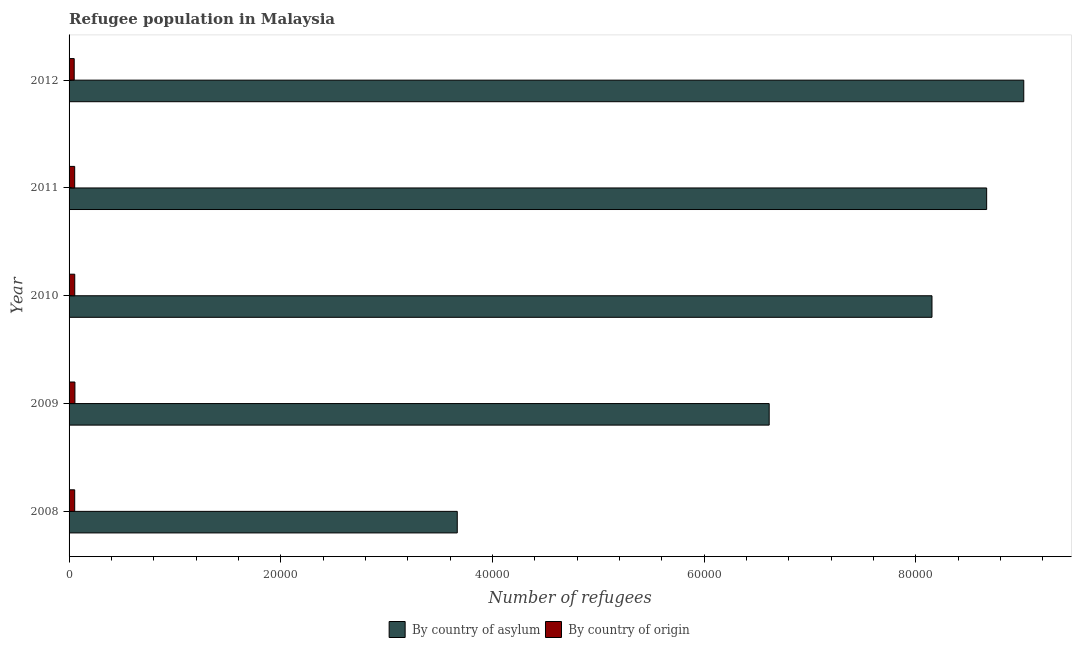How many groups of bars are there?
Keep it short and to the point. 5. How many bars are there on the 1st tick from the top?
Provide a short and direct response. 2. What is the number of refugees by country of origin in 2011?
Your answer should be very brief. 531. Across all years, what is the maximum number of refugees by country of origin?
Your answer should be very brief. 552. Across all years, what is the minimum number of refugees by country of origin?
Your response must be concise. 485. In which year was the number of refugees by country of origin maximum?
Your answer should be compact. 2009. In which year was the number of refugees by country of asylum minimum?
Ensure brevity in your answer.  2008. What is the total number of refugees by country of origin in the graph?
Provide a short and direct response. 2637. What is the difference between the number of refugees by country of origin in 2009 and that in 2012?
Make the answer very short. 67. What is the difference between the number of refugees by country of asylum in 2008 and the number of refugees by country of origin in 2012?
Your answer should be compact. 3.62e+04. What is the average number of refugees by country of origin per year?
Ensure brevity in your answer.  527.4. In the year 2011, what is the difference between the number of refugees by country of asylum and number of refugees by country of origin?
Provide a succinct answer. 8.61e+04. In how many years, is the number of refugees by country of origin greater than 12000 ?
Your answer should be very brief. 0. What is the ratio of the number of refugees by country of asylum in 2008 to that in 2011?
Ensure brevity in your answer.  0.42. What is the difference between the highest and the second highest number of refugees by country of origin?
Keep it short and to the point. 15. What is the difference between the highest and the lowest number of refugees by country of origin?
Provide a succinct answer. 67. Is the sum of the number of refugees by country of asylum in 2011 and 2012 greater than the maximum number of refugees by country of origin across all years?
Ensure brevity in your answer.  Yes. What does the 2nd bar from the top in 2010 represents?
Make the answer very short. By country of asylum. What does the 2nd bar from the bottom in 2009 represents?
Provide a succinct answer. By country of origin. How many bars are there?
Make the answer very short. 10. How many years are there in the graph?
Give a very brief answer. 5. Does the graph contain grids?
Provide a succinct answer. No. Where does the legend appear in the graph?
Your answer should be compact. Bottom center. What is the title of the graph?
Provide a short and direct response. Refugee population in Malaysia. Does "Female labourers" appear as one of the legend labels in the graph?
Your answer should be very brief. No. What is the label or title of the X-axis?
Provide a succinct answer. Number of refugees. What is the Number of refugees of By country of asylum in 2008?
Give a very brief answer. 3.67e+04. What is the Number of refugees of By country of origin in 2008?
Provide a short and direct response. 532. What is the Number of refugees of By country of asylum in 2009?
Your answer should be very brief. 6.61e+04. What is the Number of refugees of By country of origin in 2009?
Ensure brevity in your answer.  552. What is the Number of refugees of By country of asylum in 2010?
Provide a succinct answer. 8.15e+04. What is the Number of refugees of By country of origin in 2010?
Ensure brevity in your answer.  537. What is the Number of refugees of By country of asylum in 2011?
Provide a succinct answer. 8.67e+04. What is the Number of refugees in By country of origin in 2011?
Offer a terse response. 531. What is the Number of refugees in By country of asylum in 2012?
Ensure brevity in your answer.  9.02e+04. What is the Number of refugees in By country of origin in 2012?
Make the answer very short. 485. Across all years, what is the maximum Number of refugees of By country of asylum?
Give a very brief answer. 9.02e+04. Across all years, what is the maximum Number of refugees of By country of origin?
Your answer should be very brief. 552. Across all years, what is the minimum Number of refugees of By country of asylum?
Offer a terse response. 3.67e+04. Across all years, what is the minimum Number of refugees in By country of origin?
Your answer should be compact. 485. What is the total Number of refugees of By country of asylum in the graph?
Ensure brevity in your answer.  3.61e+05. What is the total Number of refugees in By country of origin in the graph?
Your response must be concise. 2637. What is the difference between the Number of refugees of By country of asylum in 2008 and that in 2009?
Offer a very short reply. -2.95e+04. What is the difference between the Number of refugees in By country of asylum in 2008 and that in 2010?
Provide a short and direct response. -4.48e+04. What is the difference between the Number of refugees in By country of origin in 2008 and that in 2010?
Offer a terse response. -5. What is the difference between the Number of refugees in By country of asylum in 2008 and that in 2011?
Give a very brief answer. -5.00e+04. What is the difference between the Number of refugees of By country of asylum in 2008 and that in 2012?
Your answer should be compact. -5.35e+04. What is the difference between the Number of refugees in By country of origin in 2008 and that in 2012?
Make the answer very short. 47. What is the difference between the Number of refugees of By country of asylum in 2009 and that in 2010?
Offer a very short reply. -1.54e+04. What is the difference between the Number of refugees of By country of asylum in 2009 and that in 2011?
Offer a terse response. -2.05e+04. What is the difference between the Number of refugees in By country of origin in 2009 and that in 2011?
Keep it short and to the point. 21. What is the difference between the Number of refugees of By country of asylum in 2009 and that in 2012?
Your answer should be compact. -2.40e+04. What is the difference between the Number of refugees in By country of asylum in 2010 and that in 2011?
Your answer should be compact. -5164. What is the difference between the Number of refugees in By country of origin in 2010 and that in 2011?
Offer a terse response. 6. What is the difference between the Number of refugees in By country of asylum in 2010 and that in 2012?
Ensure brevity in your answer.  -8669. What is the difference between the Number of refugees of By country of asylum in 2011 and that in 2012?
Offer a terse response. -3505. What is the difference between the Number of refugees of By country of origin in 2011 and that in 2012?
Offer a very short reply. 46. What is the difference between the Number of refugees of By country of asylum in 2008 and the Number of refugees of By country of origin in 2009?
Make the answer very short. 3.61e+04. What is the difference between the Number of refugees in By country of asylum in 2008 and the Number of refugees in By country of origin in 2010?
Offer a terse response. 3.61e+04. What is the difference between the Number of refugees in By country of asylum in 2008 and the Number of refugees in By country of origin in 2011?
Your answer should be compact. 3.61e+04. What is the difference between the Number of refugees in By country of asylum in 2008 and the Number of refugees in By country of origin in 2012?
Provide a succinct answer. 3.62e+04. What is the difference between the Number of refugees in By country of asylum in 2009 and the Number of refugees in By country of origin in 2010?
Offer a terse response. 6.56e+04. What is the difference between the Number of refugees in By country of asylum in 2009 and the Number of refugees in By country of origin in 2011?
Give a very brief answer. 6.56e+04. What is the difference between the Number of refugees in By country of asylum in 2009 and the Number of refugees in By country of origin in 2012?
Your answer should be very brief. 6.57e+04. What is the difference between the Number of refugees of By country of asylum in 2010 and the Number of refugees of By country of origin in 2011?
Make the answer very short. 8.10e+04. What is the difference between the Number of refugees of By country of asylum in 2010 and the Number of refugees of By country of origin in 2012?
Give a very brief answer. 8.10e+04. What is the difference between the Number of refugees of By country of asylum in 2011 and the Number of refugees of By country of origin in 2012?
Offer a very short reply. 8.62e+04. What is the average Number of refugees in By country of asylum per year?
Your answer should be very brief. 7.22e+04. What is the average Number of refugees in By country of origin per year?
Your answer should be compact. 527.4. In the year 2008, what is the difference between the Number of refugees in By country of asylum and Number of refugees in By country of origin?
Your answer should be compact. 3.61e+04. In the year 2009, what is the difference between the Number of refugees of By country of asylum and Number of refugees of By country of origin?
Ensure brevity in your answer.  6.56e+04. In the year 2010, what is the difference between the Number of refugees in By country of asylum and Number of refugees in By country of origin?
Offer a terse response. 8.10e+04. In the year 2011, what is the difference between the Number of refugees in By country of asylum and Number of refugees in By country of origin?
Keep it short and to the point. 8.61e+04. In the year 2012, what is the difference between the Number of refugees of By country of asylum and Number of refugees of By country of origin?
Keep it short and to the point. 8.97e+04. What is the ratio of the Number of refugees of By country of asylum in 2008 to that in 2009?
Give a very brief answer. 0.55. What is the ratio of the Number of refugees of By country of origin in 2008 to that in 2009?
Offer a terse response. 0.96. What is the ratio of the Number of refugees of By country of asylum in 2008 to that in 2010?
Ensure brevity in your answer.  0.45. What is the ratio of the Number of refugees in By country of origin in 2008 to that in 2010?
Your answer should be compact. 0.99. What is the ratio of the Number of refugees in By country of asylum in 2008 to that in 2011?
Offer a very short reply. 0.42. What is the ratio of the Number of refugees of By country of asylum in 2008 to that in 2012?
Offer a very short reply. 0.41. What is the ratio of the Number of refugees in By country of origin in 2008 to that in 2012?
Ensure brevity in your answer.  1.1. What is the ratio of the Number of refugees in By country of asylum in 2009 to that in 2010?
Offer a very short reply. 0.81. What is the ratio of the Number of refugees of By country of origin in 2009 to that in 2010?
Give a very brief answer. 1.03. What is the ratio of the Number of refugees of By country of asylum in 2009 to that in 2011?
Offer a very short reply. 0.76. What is the ratio of the Number of refugees of By country of origin in 2009 to that in 2011?
Ensure brevity in your answer.  1.04. What is the ratio of the Number of refugees in By country of asylum in 2009 to that in 2012?
Ensure brevity in your answer.  0.73. What is the ratio of the Number of refugees in By country of origin in 2009 to that in 2012?
Give a very brief answer. 1.14. What is the ratio of the Number of refugees of By country of asylum in 2010 to that in 2011?
Provide a short and direct response. 0.94. What is the ratio of the Number of refugees of By country of origin in 2010 to that in 2011?
Offer a terse response. 1.01. What is the ratio of the Number of refugees in By country of asylum in 2010 to that in 2012?
Provide a short and direct response. 0.9. What is the ratio of the Number of refugees in By country of origin in 2010 to that in 2012?
Offer a very short reply. 1.11. What is the ratio of the Number of refugees in By country of asylum in 2011 to that in 2012?
Provide a short and direct response. 0.96. What is the ratio of the Number of refugees in By country of origin in 2011 to that in 2012?
Ensure brevity in your answer.  1.09. What is the difference between the highest and the second highest Number of refugees of By country of asylum?
Ensure brevity in your answer.  3505. What is the difference between the highest and the lowest Number of refugees in By country of asylum?
Keep it short and to the point. 5.35e+04. 